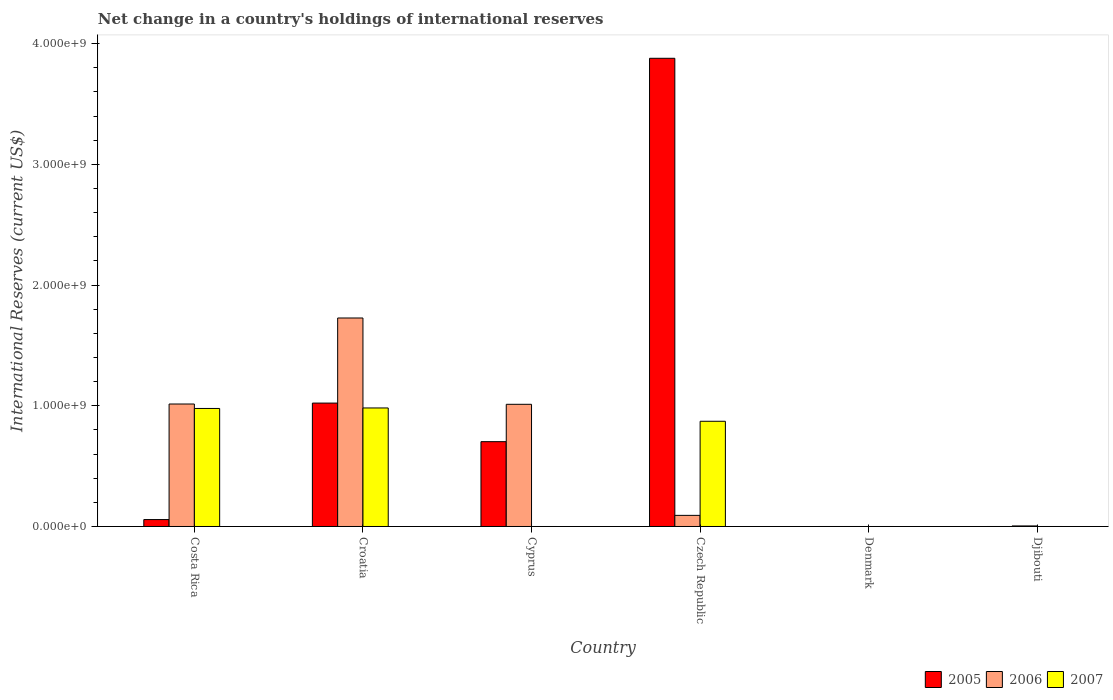Are the number of bars per tick equal to the number of legend labels?
Give a very brief answer. No. Are the number of bars on each tick of the X-axis equal?
Make the answer very short. No. What is the label of the 3rd group of bars from the left?
Your answer should be compact. Cyprus. What is the international reserves in 2005 in Czech Republic?
Keep it short and to the point. 3.88e+09. Across all countries, what is the maximum international reserves in 2007?
Ensure brevity in your answer.  9.82e+08. Across all countries, what is the minimum international reserves in 2007?
Your answer should be very brief. 0. In which country was the international reserves in 2007 maximum?
Provide a succinct answer. Croatia. What is the total international reserves in 2005 in the graph?
Give a very brief answer. 5.66e+09. What is the difference between the international reserves in 2005 in Croatia and that in Czech Republic?
Ensure brevity in your answer.  -2.86e+09. What is the difference between the international reserves in 2007 in Czech Republic and the international reserves in 2006 in Djibouti?
Offer a terse response. 8.67e+08. What is the average international reserves in 2007 per country?
Ensure brevity in your answer.  4.72e+08. What is the difference between the international reserves of/in 2006 and international reserves of/in 2007 in Costa Rica?
Ensure brevity in your answer.  3.69e+07. In how many countries, is the international reserves in 2006 greater than 1200000000 US$?
Your answer should be very brief. 1. What is the ratio of the international reserves in 2006 in Croatia to that in Czech Republic?
Your answer should be compact. 18.76. What is the difference between the highest and the second highest international reserves in 2007?
Your response must be concise. 4.17e+06. What is the difference between the highest and the lowest international reserves in 2005?
Offer a terse response. 3.88e+09. How many bars are there?
Make the answer very short. 12. Are all the bars in the graph horizontal?
Keep it short and to the point. No. How many countries are there in the graph?
Ensure brevity in your answer.  6. Are the values on the major ticks of Y-axis written in scientific E-notation?
Your answer should be compact. Yes. Does the graph contain any zero values?
Your answer should be very brief. Yes. Does the graph contain grids?
Your answer should be very brief. No. How many legend labels are there?
Offer a very short reply. 3. What is the title of the graph?
Your answer should be very brief. Net change in a country's holdings of international reserves. Does "1978" appear as one of the legend labels in the graph?
Make the answer very short. No. What is the label or title of the Y-axis?
Your answer should be very brief. International Reserves (current US$). What is the International Reserves (current US$) in 2005 in Costa Rica?
Offer a terse response. 5.72e+07. What is the International Reserves (current US$) of 2006 in Costa Rica?
Your answer should be compact. 1.01e+09. What is the International Reserves (current US$) in 2007 in Costa Rica?
Provide a succinct answer. 9.78e+08. What is the International Reserves (current US$) in 2005 in Croatia?
Your answer should be compact. 1.02e+09. What is the International Reserves (current US$) in 2006 in Croatia?
Your answer should be compact. 1.73e+09. What is the International Reserves (current US$) of 2007 in Croatia?
Provide a short and direct response. 9.82e+08. What is the International Reserves (current US$) in 2005 in Cyprus?
Offer a very short reply. 7.03e+08. What is the International Reserves (current US$) of 2006 in Cyprus?
Provide a short and direct response. 1.01e+09. What is the International Reserves (current US$) of 2005 in Czech Republic?
Make the answer very short. 3.88e+09. What is the International Reserves (current US$) in 2006 in Czech Republic?
Offer a very short reply. 9.21e+07. What is the International Reserves (current US$) of 2007 in Czech Republic?
Provide a succinct answer. 8.72e+08. What is the International Reserves (current US$) of 2005 in Denmark?
Your answer should be very brief. 0. What is the International Reserves (current US$) of 2006 in Denmark?
Give a very brief answer. 0. What is the International Reserves (current US$) in 2005 in Djibouti?
Provide a succinct answer. 0. What is the International Reserves (current US$) in 2006 in Djibouti?
Provide a succinct answer. 4.65e+06. Across all countries, what is the maximum International Reserves (current US$) of 2005?
Provide a short and direct response. 3.88e+09. Across all countries, what is the maximum International Reserves (current US$) in 2006?
Ensure brevity in your answer.  1.73e+09. Across all countries, what is the maximum International Reserves (current US$) in 2007?
Make the answer very short. 9.82e+08. Across all countries, what is the minimum International Reserves (current US$) in 2006?
Make the answer very short. 0. Across all countries, what is the minimum International Reserves (current US$) of 2007?
Provide a succinct answer. 0. What is the total International Reserves (current US$) in 2005 in the graph?
Provide a short and direct response. 5.66e+09. What is the total International Reserves (current US$) in 2006 in the graph?
Your answer should be compact. 3.85e+09. What is the total International Reserves (current US$) of 2007 in the graph?
Your response must be concise. 2.83e+09. What is the difference between the International Reserves (current US$) of 2005 in Costa Rica and that in Croatia?
Offer a terse response. -9.65e+08. What is the difference between the International Reserves (current US$) of 2006 in Costa Rica and that in Croatia?
Your response must be concise. -7.13e+08. What is the difference between the International Reserves (current US$) of 2007 in Costa Rica and that in Croatia?
Make the answer very short. -4.17e+06. What is the difference between the International Reserves (current US$) in 2005 in Costa Rica and that in Cyprus?
Provide a succinct answer. -6.45e+08. What is the difference between the International Reserves (current US$) of 2006 in Costa Rica and that in Cyprus?
Your answer should be compact. 2.44e+06. What is the difference between the International Reserves (current US$) of 2005 in Costa Rica and that in Czech Republic?
Offer a very short reply. -3.82e+09. What is the difference between the International Reserves (current US$) of 2006 in Costa Rica and that in Czech Republic?
Your response must be concise. 9.23e+08. What is the difference between the International Reserves (current US$) in 2007 in Costa Rica and that in Czech Republic?
Ensure brevity in your answer.  1.06e+08. What is the difference between the International Reserves (current US$) in 2006 in Costa Rica and that in Djibouti?
Ensure brevity in your answer.  1.01e+09. What is the difference between the International Reserves (current US$) of 2005 in Croatia and that in Cyprus?
Provide a short and direct response. 3.20e+08. What is the difference between the International Reserves (current US$) in 2006 in Croatia and that in Cyprus?
Provide a short and direct response. 7.15e+08. What is the difference between the International Reserves (current US$) in 2005 in Croatia and that in Czech Republic?
Give a very brief answer. -2.86e+09. What is the difference between the International Reserves (current US$) in 2006 in Croatia and that in Czech Republic?
Keep it short and to the point. 1.64e+09. What is the difference between the International Reserves (current US$) in 2007 in Croatia and that in Czech Republic?
Your answer should be compact. 1.10e+08. What is the difference between the International Reserves (current US$) in 2006 in Croatia and that in Djibouti?
Make the answer very short. 1.72e+09. What is the difference between the International Reserves (current US$) in 2005 in Cyprus and that in Czech Republic?
Give a very brief answer. -3.18e+09. What is the difference between the International Reserves (current US$) of 2006 in Cyprus and that in Czech Republic?
Provide a succinct answer. 9.20e+08. What is the difference between the International Reserves (current US$) of 2006 in Cyprus and that in Djibouti?
Your answer should be very brief. 1.01e+09. What is the difference between the International Reserves (current US$) of 2006 in Czech Republic and that in Djibouti?
Provide a succinct answer. 8.74e+07. What is the difference between the International Reserves (current US$) in 2005 in Costa Rica and the International Reserves (current US$) in 2006 in Croatia?
Provide a short and direct response. -1.67e+09. What is the difference between the International Reserves (current US$) of 2005 in Costa Rica and the International Reserves (current US$) of 2007 in Croatia?
Your answer should be compact. -9.25e+08. What is the difference between the International Reserves (current US$) of 2006 in Costa Rica and the International Reserves (current US$) of 2007 in Croatia?
Keep it short and to the point. 3.28e+07. What is the difference between the International Reserves (current US$) of 2005 in Costa Rica and the International Reserves (current US$) of 2006 in Cyprus?
Keep it short and to the point. -9.55e+08. What is the difference between the International Reserves (current US$) in 2005 in Costa Rica and the International Reserves (current US$) in 2006 in Czech Republic?
Your answer should be very brief. -3.48e+07. What is the difference between the International Reserves (current US$) of 2005 in Costa Rica and the International Reserves (current US$) of 2007 in Czech Republic?
Offer a terse response. -8.14e+08. What is the difference between the International Reserves (current US$) in 2006 in Costa Rica and the International Reserves (current US$) in 2007 in Czech Republic?
Your response must be concise. 1.43e+08. What is the difference between the International Reserves (current US$) of 2005 in Costa Rica and the International Reserves (current US$) of 2006 in Djibouti?
Offer a terse response. 5.26e+07. What is the difference between the International Reserves (current US$) in 2005 in Croatia and the International Reserves (current US$) in 2006 in Cyprus?
Your answer should be compact. 1.01e+07. What is the difference between the International Reserves (current US$) of 2005 in Croatia and the International Reserves (current US$) of 2006 in Czech Republic?
Offer a very short reply. 9.30e+08. What is the difference between the International Reserves (current US$) in 2005 in Croatia and the International Reserves (current US$) in 2007 in Czech Republic?
Make the answer very short. 1.51e+08. What is the difference between the International Reserves (current US$) of 2006 in Croatia and the International Reserves (current US$) of 2007 in Czech Republic?
Provide a short and direct response. 8.56e+08. What is the difference between the International Reserves (current US$) in 2005 in Croatia and the International Reserves (current US$) in 2006 in Djibouti?
Provide a succinct answer. 1.02e+09. What is the difference between the International Reserves (current US$) in 2005 in Cyprus and the International Reserves (current US$) in 2006 in Czech Republic?
Keep it short and to the point. 6.11e+08. What is the difference between the International Reserves (current US$) of 2005 in Cyprus and the International Reserves (current US$) of 2007 in Czech Republic?
Offer a terse response. -1.69e+08. What is the difference between the International Reserves (current US$) in 2006 in Cyprus and the International Reserves (current US$) in 2007 in Czech Republic?
Ensure brevity in your answer.  1.41e+08. What is the difference between the International Reserves (current US$) in 2005 in Cyprus and the International Reserves (current US$) in 2006 in Djibouti?
Offer a very short reply. 6.98e+08. What is the difference between the International Reserves (current US$) in 2005 in Czech Republic and the International Reserves (current US$) in 2006 in Djibouti?
Provide a succinct answer. 3.87e+09. What is the average International Reserves (current US$) in 2005 per country?
Ensure brevity in your answer.  9.44e+08. What is the average International Reserves (current US$) in 2006 per country?
Ensure brevity in your answer.  6.42e+08. What is the average International Reserves (current US$) of 2007 per country?
Give a very brief answer. 4.72e+08. What is the difference between the International Reserves (current US$) in 2005 and International Reserves (current US$) in 2006 in Costa Rica?
Your response must be concise. -9.57e+08. What is the difference between the International Reserves (current US$) of 2005 and International Reserves (current US$) of 2007 in Costa Rica?
Give a very brief answer. -9.20e+08. What is the difference between the International Reserves (current US$) of 2006 and International Reserves (current US$) of 2007 in Costa Rica?
Provide a succinct answer. 3.69e+07. What is the difference between the International Reserves (current US$) of 2005 and International Reserves (current US$) of 2006 in Croatia?
Ensure brevity in your answer.  -7.05e+08. What is the difference between the International Reserves (current US$) of 2005 and International Reserves (current US$) of 2007 in Croatia?
Give a very brief answer. 4.04e+07. What is the difference between the International Reserves (current US$) in 2006 and International Reserves (current US$) in 2007 in Croatia?
Make the answer very short. 7.45e+08. What is the difference between the International Reserves (current US$) in 2005 and International Reserves (current US$) in 2006 in Cyprus?
Your answer should be compact. -3.10e+08. What is the difference between the International Reserves (current US$) of 2005 and International Reserves (current US$) of 2006 in Czech Republic?
Keep it short and to the point. 3.79e+09. What is the difference between the International Reserves (current US$) in 2005 and International Reserves (current US$) in 2007 in Czech Republic?
Your answer should be very brief. 3.01e+09. What is the difference between the International Reserves (current US$) in 2006 and International Reserves (current US$) in 2007 in Czech Republic?
Provide a succinct answer. -7.80e+08. What is the ratio of the International Reserves (current US$) of 2005 in Costa Rica to that in Croatia?
Keep it short and to the point. 0.06. What is the ratio of the International Reserves (current US$) of 2006 in Costa Rica to that in Croatia?
Offer a very short reply. 0.59. What is the ratio of the International Reserves (current US$) in 2007 in Costa Rica to that in Croatia?
Keep it short and to the point. 1. What is the ratio of the International Reserves (current US$) in 2005 in Costa Rica to that in Cyprus?
Make the answer very short. 0.08. What is the ratio of the International Reserves (current US$) of 2005 in Costa Rica to that in Czech Republic?
Your answer should be compact. 0.01. What is the ratio of the International Reserves (current US$) in 2006 in Costa Rica to that in Czech Republic?
Your response must be concise. 11.02. What is the ratio of the International Reserves (current US$) in 2007 in Costa Rica to that in Czech Republic?
Give a very brief answer. 1.12. What is the ratio of the International Reserves (current US$) of 2006 in Costa Rica to that in Djibouti?
Give a very brief answer. 218.17. What is the ratio of the International Reserves (current US$) of 2005 in Croatia to that in Cyprus?
Your answer should be compact. 1.45. What is the ratio of the International Reserves (current US$) of 2006 in Croatia to that in Cyprus?
Provide a short and direct response. 1.71. What is the ratio of the International Reserves (current US$) of 2005 in Croatia to that in Czech Republic?
Offer a terse response. 0.26. What is the ratio of the International Reserves (current US$) of 2006 in Croatia to that in Czech Republic?
Offer a terse response. 18.76. What is the ratio of the International Reserves (current US$) in 2007 in Croatia to that in Czech Republic?
Your response must be concise. 1.13. What is the ratio of the International Reserves (current US$) of 2006 in Croatia to that in Djibouti?
Ensure brevity in your answer.  371.39. What is the ratio of the International Reserves (current US$) of 2005 in Cyprus to that in Czech Republic?
Ensure brevity in your answer.  0.18. What is the ratio of the International Reserves (current US$) of 2006 in Cyprus to that in Czech Republic?
Your answer should be compact. 10.99. What is the ratio of the International Reserves (current US$) in 2006 in Cyprus to that in Djibouti?
Provide a short and direct response. 217.65. What is the ratio of the International Reserves (current US$) in 2006 in Czech Republic to that in Djibouti?
Give a very brief answer. 19.8. What is the difference between the highest and the second highest International Reserves (current US$) of 2005?
Ensure brevity in your answer.  2.86e+09. What is the difference between the highest and the second highest International Reserves (current US$) of 2006?
Your answer should be very brief. 7.13e+08. What is the difference between the highest and the second highest International Reserves (current US$) in 2007?
Provide a short and direct response. 4.17e+06. What is the difference between the highest and the lowest International Reserves (current US$) of 2005?
Provide a succinct answer. 3.88e+09. What is the difference between the highest and the lowest International Reserves (current US$) in 2006?
Give a very brief answer. 1.73e+09. What is the difference between the highest and the lowest International Reserves (current US$) in 2007?
Ensure brevity in your answer.  9.82e+08. 